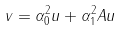Convert formula to latex. <formula><loc_0><loc_0><loc_500><loc_500>v = \alpha _ { 0 } ^ { 2 } u + \alpha _ { 1 } ^ { 2 } A u</formula> 